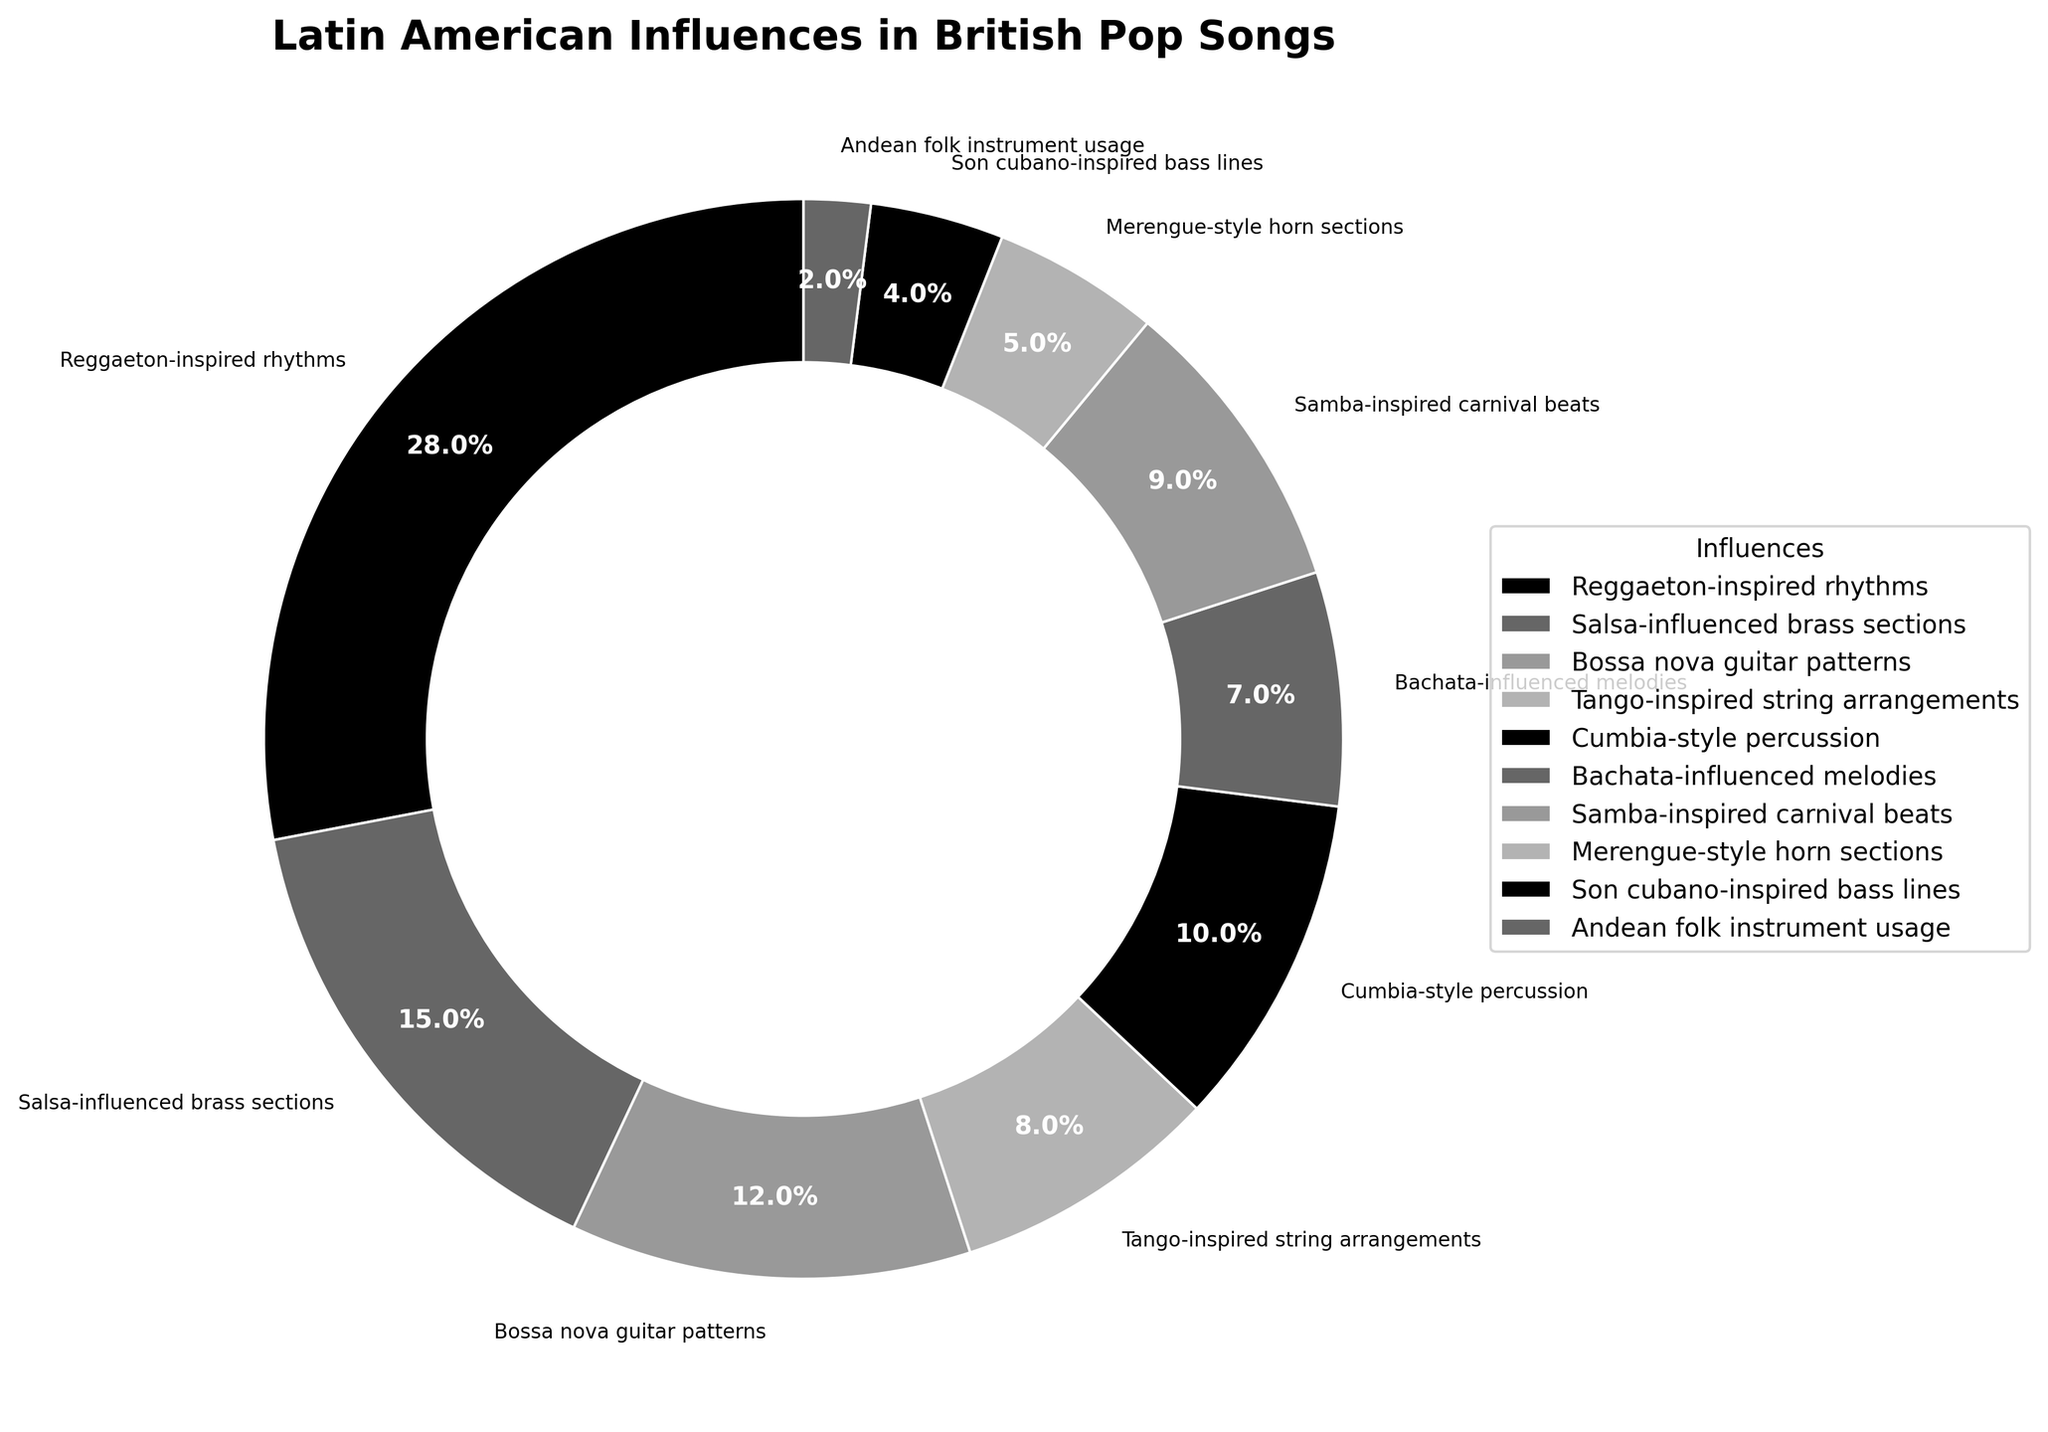what is the influence with the highest percentage? By observing the sizes of the segments in the pie chart and looking at the labels, you can determine that Reggaeton-inspired rhythms have the largest segment, representing 28%.
Answer: Reggaeton-inspired rhythms which two influences together account for over 50% of the total? Adding the percentages of the two largest segments, Reggaeton-inspired rhythms (28%) and Salsa-influenced brass sections (15%), you get 43%. Including Bossa nova guitar patterns (12%) gives a combined total of 55%.
Answer: Reggaeton-inspired rhythms and Salsa-influenced brass sections what is the combined percentage of influences related to string arrangements and horn sections? Adding the percentages of Tango-inspired string arrangements (8%) and Merengue-style horn sections (5%) equals 13%.
Answer: 13% is the percentage of Bossa nova guitar patterns greater than that of Samba-inspired carnival beats? Comparing the percentages, Bossa nova guitar patterns are at 12%, and Samba-inspired carnival beats are at 9%. Thus, Bossa nova guitar patterns have a greater percentage.
Answer: Yes how much more influence do Reggaeton-inspired rhythms have compared to Cumbia-style percussion? Subtracting the percentage of Cumbia-style percussion (10%) from Reggaeton-inspired rhythms (28%) gives 18%.
Answer: 18% which influence has the smallest percentage in the figure? By identifying the smallest segment and label in the pie chart, Andean folk instrument usage has the smallest percentage at 2%.
Answer: Andean folk instrument usage what is the total percentage of influences under 10%? Adding the percentages of influences under 10%: Tango-inspired string arrangements (8%), Cumbia-style percussion (10%), Bachata-influenced melodies (7%), Samba-inspired carnival beats (9%), Merengue-style horn sections (5%), Son cubano-inspired bass lines (4%), and Andean folk instrument usage (2%) gives a total of 45%.
Answer: 45% what percentage of the influences are related to melodic patterns? Identifying influences related to melodic patterns: Bossa nova guitar patterns (12%) and Bachata-influenced melodies (7%), the total percentage is 19%.
Answer: 19% which has a higher percentage, Salsa-influenced brass sections or Bossa nova guitar patterns? Salsa-influenced brass sections are at 15%, while Bossa nova guitar patterns are at 12%. Hence, Salsa-influenced brass sections have a higher percentage.
Answer: Salsa-influenced brass sections of the rhythm-related influences, which one has the highest percentage? For rhythm-related influences: Reggaeton-inspired rhythms (28%), Cumbia-style percussion (10%), and Samba-inspired carnival beats (9%), Reggaeton-inspired rhythms have the highest percentage at 28%.
Answer: Reggaeton-inspired rhythms 